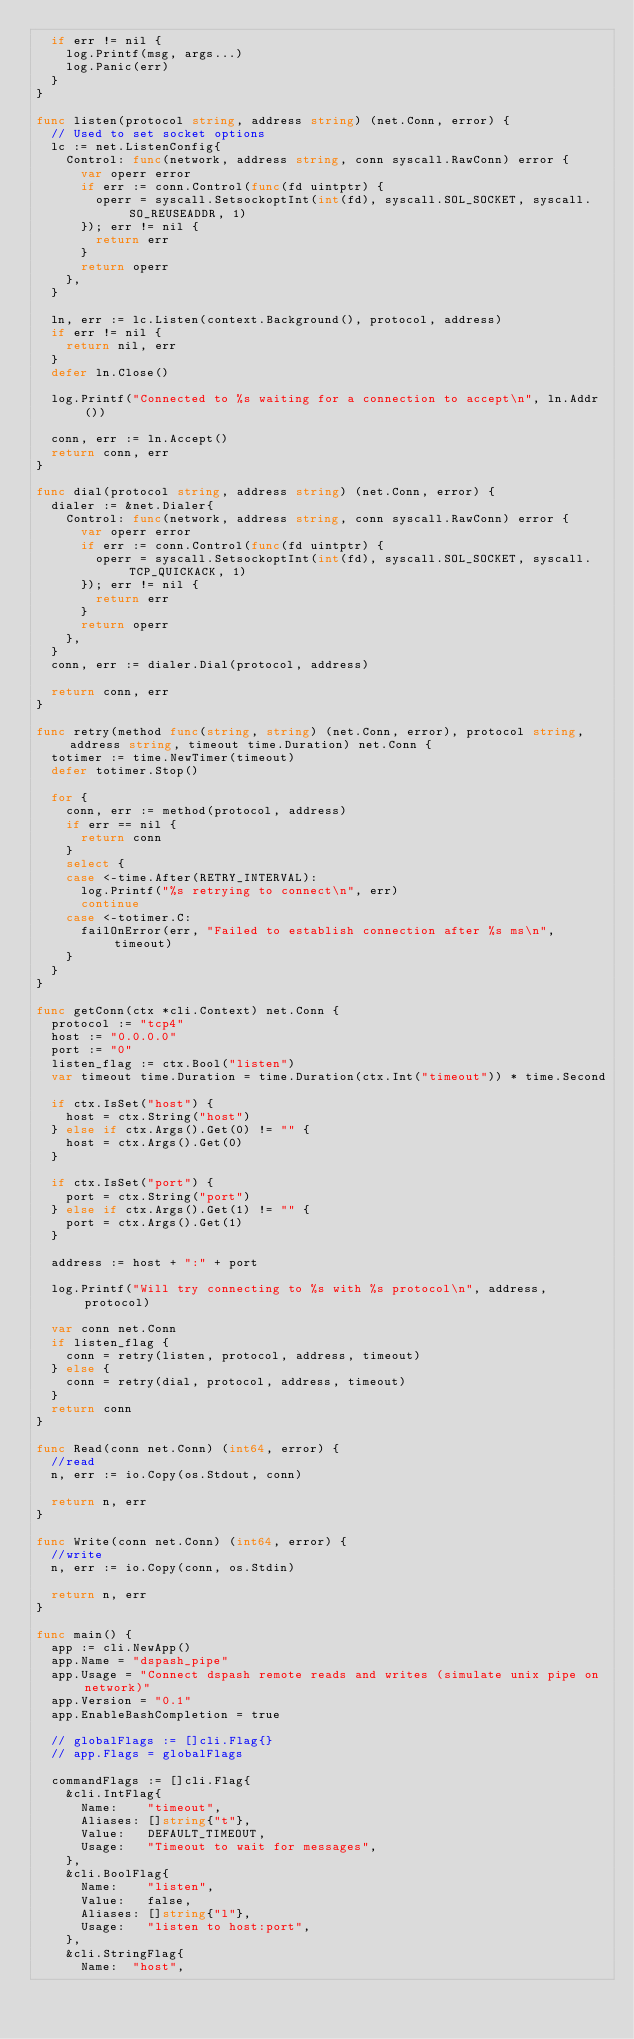Convert code to text. <code><loc_0><loc_0><loc_500><loc_500><_Go_>	if err != nil {
		log.Printf(msg, args...)
		log.Panic(err)
	}
}

func listen(protocol string, address string) (net.Conn, error) {
	// Used to set socket options
	lc := net.ListenConfig{
		Control: func(network, address string, conn syscall.RawConn) error {
			var operr error
			if err := conn.Control(func(fd uintptr) {
				operr = syscall.SetsockoptInt(int(fd), syscall.SOL_SOCKET, syscall.SO_REUSEADDR, 1)
			}); err != nil {
				return err
			}
			return operr
		},
	}

	ln, err := lc.Listen(context.Background(), protocol, address)
	if err != nil {
		return nil, err
	}
	defer ln.Close()

	log.Printf("Connected to %s waiting for a connection to accept\n", ln.Addr())

	conn, err := ln.Accept()
	return conn, err
}

func dial(protocol string, address string) (net.Conn, error) {
	dialer := &net.Dialer{
		Control: func(network, address string, conn syscall.RawConn) error {
			var operr error
			if err := conn.Control(func(fd uintptr) {
				operr = syscall.SetsockoptInt(int(fd), syscall.SOL_SOCKET, syscall.TCP_QUICKACK, 1)
			}); err != nil {
				return err
			}
			return operr
		},
	}
	conn, err := dialer.Dial(protocol, address)

	return conn, err
}

func retry(method func(string, string) (net.Conn, error), protocol string, address string, timeout time.Duration) net.Conn {
	totimer := time.NewTimer(timeout)
	defer totimer.Stop()

	for {
		conn, err := method(protocol, address)
		if err == nil {
			return conn
		}
		select {
		case <-time.After(RETRY_INTERVAL):
			log.Printf("%s retrying to connect\n", err)
			continue
		case <-totimer.C:
			failOnError(err, "Failed to establish connection after %s ms\n", timeout)
		}
	}
}

func getConn(ctx *cli.Context) net.Conn {
	protocol := "tcp4"
	host := "0.0.0.0"
	port := "0"
	listen_flag := ctx.Bool("listen")
	var timeout time.Duration = time.Duration(ctx.Int("timeout")) * time.Second

	if ctx.IsSet("host") {
		host = ctx.String("host")
	} else if ctx.Args().Get(0) != "" {
		host = ctx.Args().Get(0)
	}

	if ctx.IsSet("port") {
		port = ctx.String("port")
	} else if ctx.Args().Get(1) != "" {
		port = ctx.Args().Get(1)
	}

	address := host + ":" + port

	log.Printf("Will try connecting to %s with %s protocol\n", address, protocol)

	var conn net.Conn
	if listen_flag {
		conn = retry(listen, protocol, address, timeout)
	} else {
		conn = retry(dial, protocol, address, timeout)
	}
	return conn
}

func Read(conn net.Conn) (int64, error) {
	//read
	n, err := io.Copy(os.Stdout, conn)

	return n, err
}

func Write(conn net.Conn) (int64, error) {
	//write
	n, err := io.Copy(conn, os.Stdin)

	return n, err
}

func main() {
	app := cli.NewApp()
	app.Name = "dspash_pipe"
	app.Usage = "Connect dspash remote reads and writes (simulate unix pipe on network)"
	app.Version = "0.1"
	app.EnableBashCompletion = true

	// globalFlags := []cli.Flag{}
	// app.Flags = globalFlags

	commandFlags := []cli.Flag{
		&cli.IntFlag{
			Name:    "timeout",
			Aliases: []string{"t"},
			Value:   DEFAULT_TIMEOUT,
			Usage:   "Timeout to wait for messages",
		},
		&cli.BoolFlag{
			Name:    "listen",
			Value:   false,
			Aliases: []string{"l"},
			Usage:   "listen to host:port",
		},
		&cli.StringFlag{
			Name:  "host",</code> 